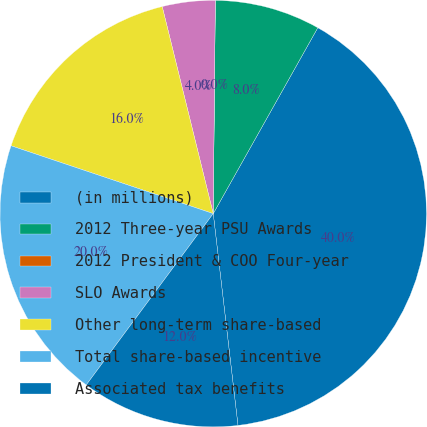Convert chart to OTSL. <chart><loc_0><loc_0><loc_500><loc_500><pie_chart><fcel>(in millions)<fcel>2012 Three-year PSU Awards<fcel>2012 President & COO Four-year<fcel>SLO Awards<fcel>Other long-term share-based<fcel>Total share-based incentive<fcel>Associated tax benefits<nl><fcel>39.99%<fcel>8.0%<fcel>0.0%<fcel>4.0%<fcel>16.0%<fcel>20.0%<fcel>12.0%<nl></chart> 